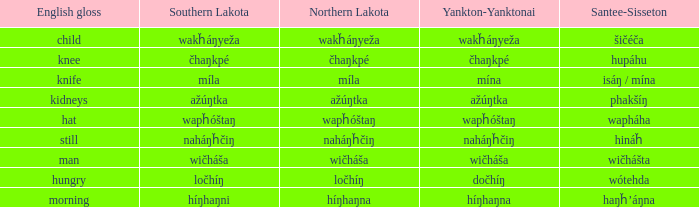Name the santee sisseton for wičháša Wičhášta. 